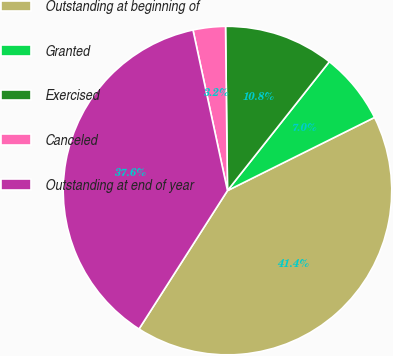<chart> <loc_0><loc_0><loc_500><loc_500><pie_chart><fcel>Outstanding at beginning of<fcel>Granted<fcel>Exercised<fcel>Canceled<fcel>Outstanding at end of year<nl><fcel>41.4%<fcel>7.01%<fcel>10.83%<fcel>3.18%<fcel>37.58%<nl></chart> 